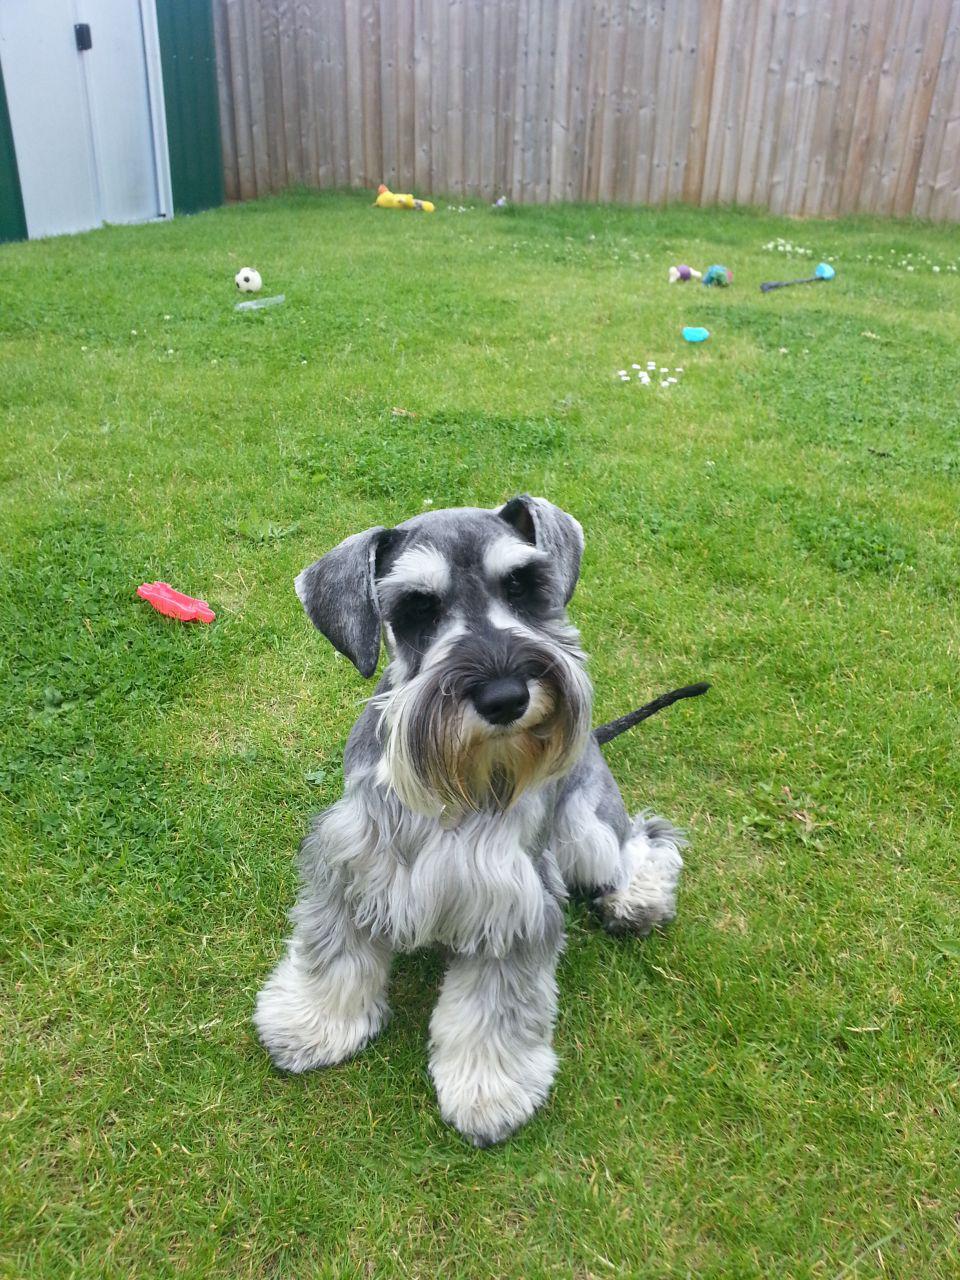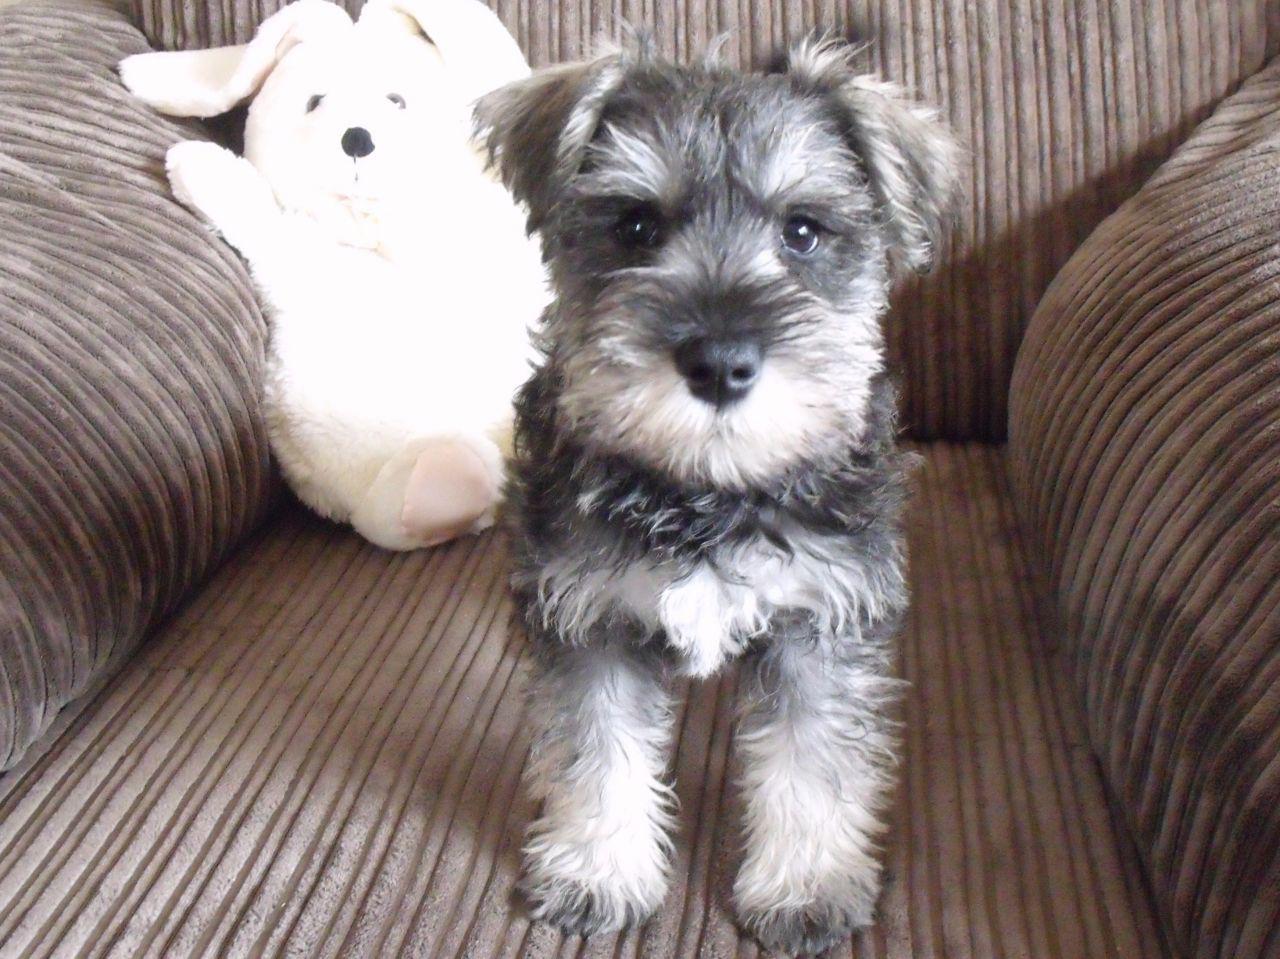The first image is the image on the left, the second image is the image on the right. For the images displayed, is the sentence "The right image contains no more than one dog." factually correct? Answer yes or no. Yes. The first image is the image on the left, the second image is the image on the right. Evaluate the accuracy of this statement regarding the images: "There are at most two dogs.". Is it true? Answer yes or no. Yes. 